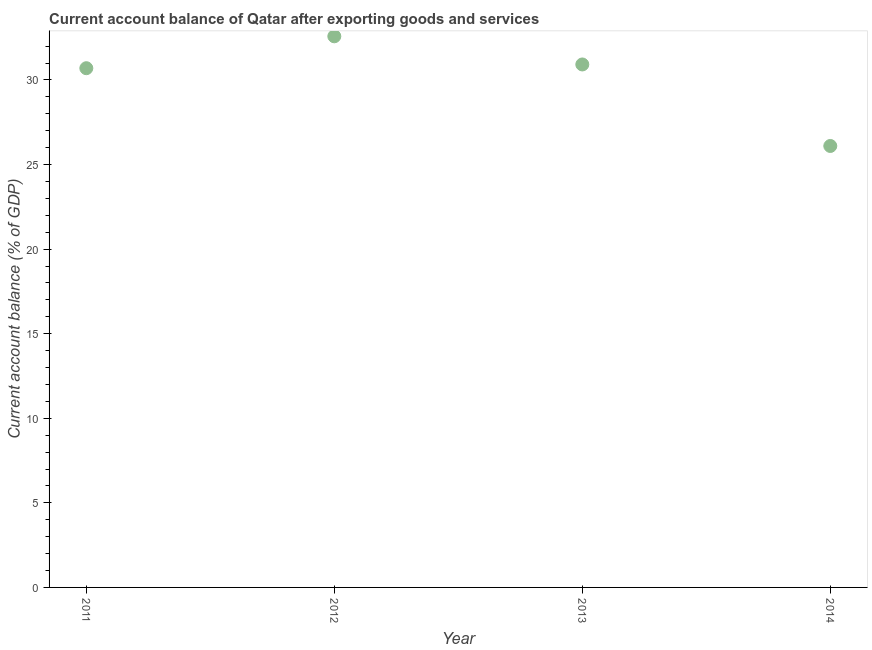What is the current account balance in 2012?
Keep it short and to the point. 32.58. Across all years, what is the maximum current account balance?
Keep it short and to the point. 32.58. Across all years, what is the minimum current account balance?
Ensure brevity in your answer.  26.1. In which year was the current account balance minimum?
Give a very brief answer. 2014. What is the sum of the current account balance?
Keep it short and to the point. 120.29. What is the difference between the current account balance in 2011 and 2012?
Your answer should be very brief. -1.89. What is the average current account balance per year?
Provide a succinct answer. 30.07. What is the median current account balance?
Give a very brief answer. 30.81. In how many years, is the current account balance greater than 9 %?
Your answer should be very brief. 4. What is the ratio of the current account balance in 2012 to that in 2014?
Ensure brevity in your answer.  1.25. What is the difference between the highest and the second highest current account balance?
Give a very brief answer. 1.66. What is the difference between the highest and the lowest current account balance?
Provide a succinct answer. 6.48. In how many years, is the current account balance greater than the average current account balance taken over all years?
Your response must be concise. 3. Does the current account balance monotonically increase over the years?
Your answer should be compact. No. How many years are there in the graph?
Ensure brevity in your answer.  4. What is the difference between two consecutive major ticks on the Y-axis?
Offer a terse response. 5. Are the values on the major ticks of Y-axis written in scientific E-notation?
Provide a succinct answer. No. Does the graph contain grids?
Give a very brief answer. No. What is the title of the graph?
Provide a short and direct response. Current account balance of Qatar after exporting goods and services. What is the label or title of the X-axis?
Your answer should be compact. Year. What is the label or title of the Y-axis?
Provide a succinct answer. Current account balance (% of GDP). What is the Current account balance (% of GDP) in 2011?
Make the answer very short. 30.7. What is the Current account balance (% of GDP) in 2012?
Ensure brevity in your answer.  32.58. What is the Current account balance (% of GDP) in 2013?
Offer a terse response. 30.92. What is the Current account balance (% of GDP) in 2014?
Provide a succinct answer. 26.1. What is the difference between the Current account balance (% of GDP) in 2011 and 2012?
Your response must be concise. -1.89. What is the difference between the Current account balance (% of GDP) in 2011 and 2013?
Ensure brevity in your answer.  -0.22. What is the difference between the Current account balance (% of GDP) in 2011 and 2014?
Keep it short and to the point. 4.6. What is the difference between the Current account balance (% of GDP) in 2012 and 2013?
Keep it short and to the point. 1.66. What is the difference between the Current account balance (% of GDP) in 2012 and 2014?
Make the answer very short. 6.48. What is the difference between the Current account balance (% of GDP) in 2013 and 2014?
Provide a short and direct response. 4.82. What is the ratio of the Current account balance (% of GDP) in 2011 to that in 2012?
Your answer should be compact. 0.94. What is the ratio of the Current account balance (% of GDP) in 2011 to that in 2014?
Your answer should be compact. 1.18. What is the ratio of the Current account balance (% of GDP) in 2012 to that in 2013?
Your answer should be compact. 1.05. What is the ratio of the Current account balance (% of GDP) in 2012 to that in 2014?
Offer a very short reply. 1.25. What is the ratio of the Current account balance (% of GDP) in 2013 to that in 2014?
Keep it short and to the point. 1.19. 